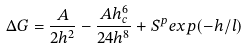<formula> <loc_0><loc_0><loc_500><loc_500>\Delta G = \frac { A } { 2 h ^ { 2 } } - \frac { A h _ { c } ^ { 6 } } { 2 4 h ^ { 8 } } + S ^ { p } e x p ( - h / l )</formula> 